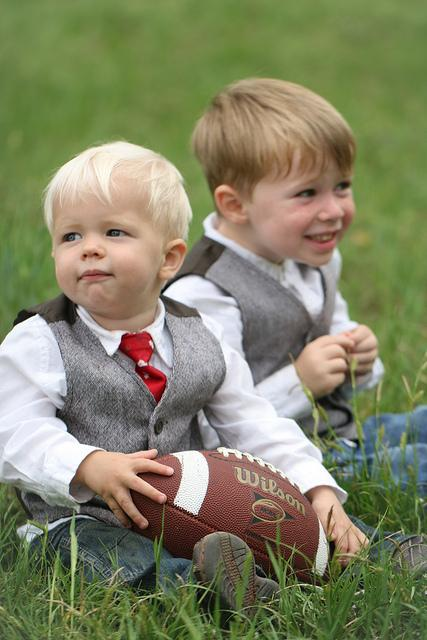What British sport could this ball be used for? Please explain your reasoning. rugby. Football is used in rugby. 